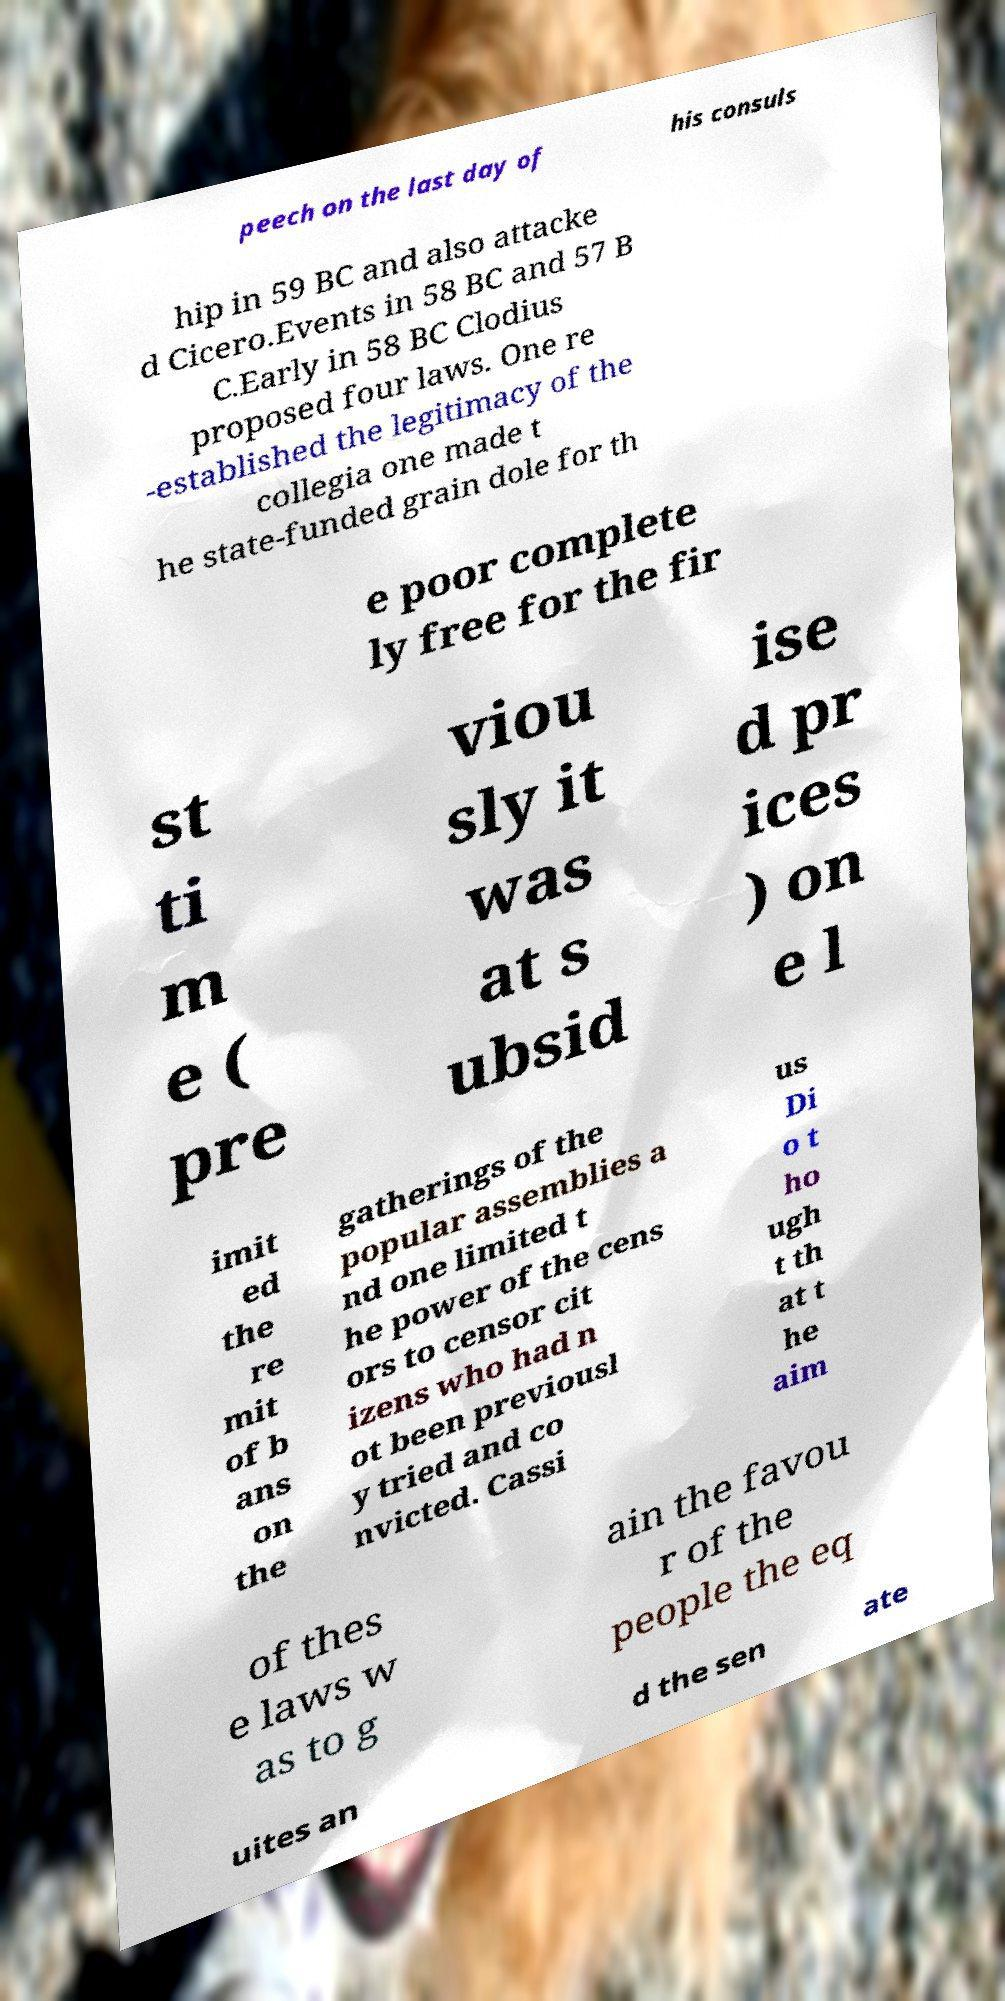What messages or text are displayed in this image? I need them in a readable, typed format. peech on the last day of his consuls hip in 59 BC and also attacke d Cicero.Events in 58 BC and 57 B C.Early in 58 BC Clodius proposed four laws. One re -established the legitimacy of the collegia one made t he state-funded grain dole for th e poor complete ly free for the fir st ti m e ( pre viou sly it was at s ubsid ise d pr ices ) on e l imit ed the re mit of b ans on the gatherings of the popular assemblies a nd one limited t he power of the cens ors to censor cit izens who had n ot been previousl y tried and co nvicted. Cassi us Di o t ho ugh t th at t he aim of thes e laws w as to g ain the favou r of the people the eq uites an d the sen ate 